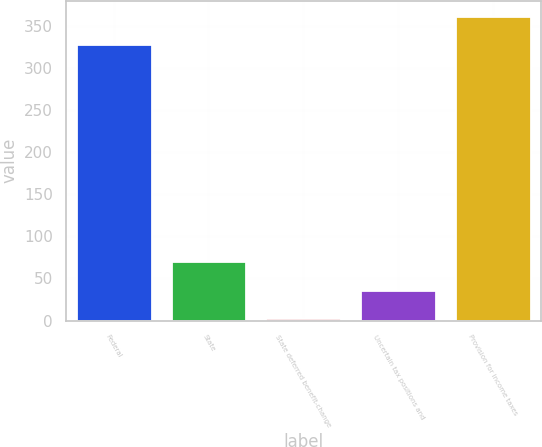Convert chart to OTSL. <chart><loc_0><loc_0><loc_500><loc_500><bar_chart><fcel>Federal<fcel>State<fcel>State deferred benefit-change<fcel>Uncertain tax positions and<fcel>Provision for income taxes<nl><fcel>328.1<fcel>70.04<fcel>3.2<fcel>36.62<fcel>361.52<nl></chart> 